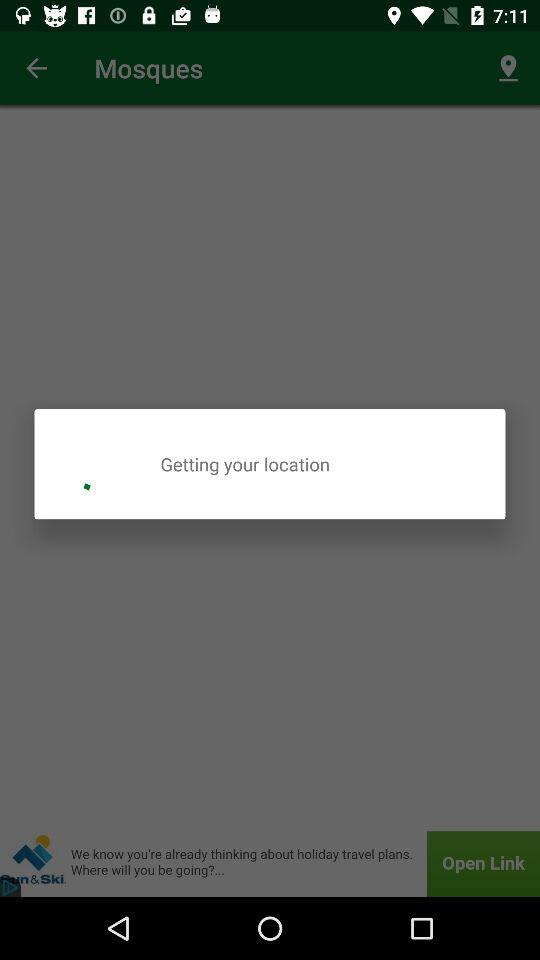Where is the user located?
When the provided information is insufficient, respond with <no answer>. <no answer> 